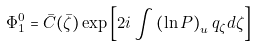Convert formula to latex. <formula><loc_0><loc_0><loc_500><loc_500>\Phi _ { 1 } ^ { 0 } = \bar { C } ( \bar { \zeta } ) \exp \left [ 2 i \int \left ( \ln P \right ) _ { u } q _ { \zeta } d \zeta \right ]</formula> 